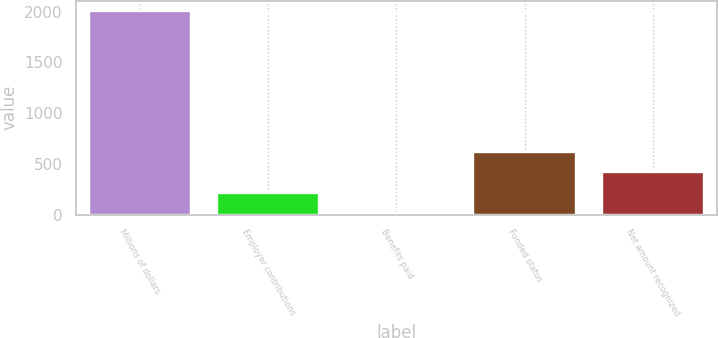Convert chart to OTSL. <chart><loc_0><loc_0><loc_500><loc_500><bar_chart><fcel>Millions of dollars<fcel>Employer contributions<fcel>Benefits paid<fcel>Funded status<fcel>Net amount recognized<nl><fcel>2007<fcel>216<fcel>17<fcel>614<fcel>415<nl></chart> 